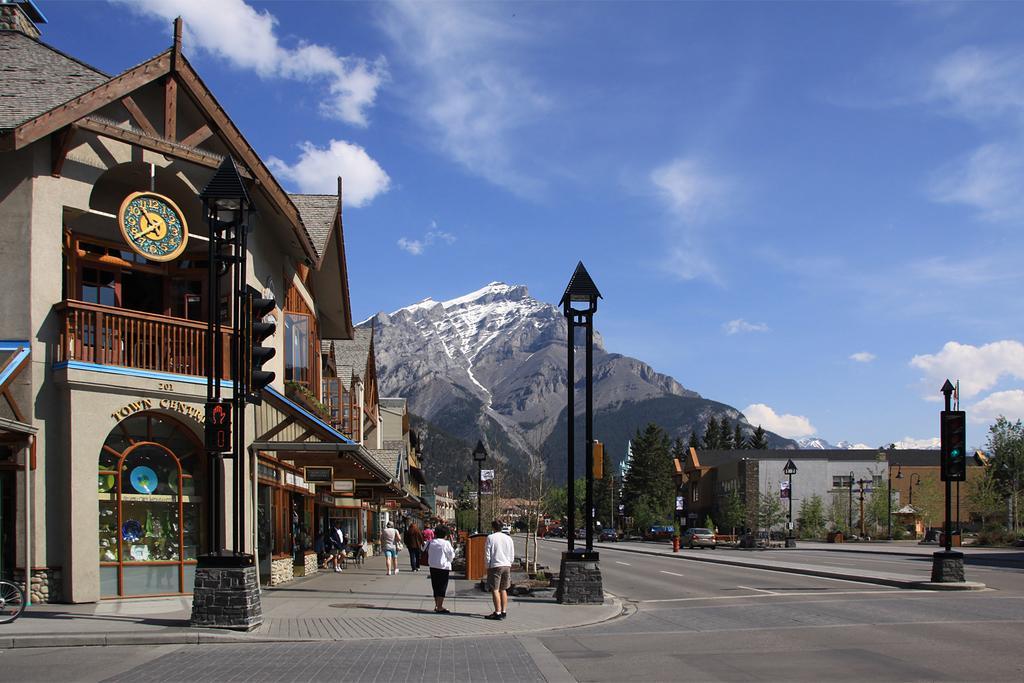How would you summarize this image in a sentence or two? This is the picture of a place where we have a building to which there is a clock and a fencing and around there are some poles, trees, people and some other things around. 